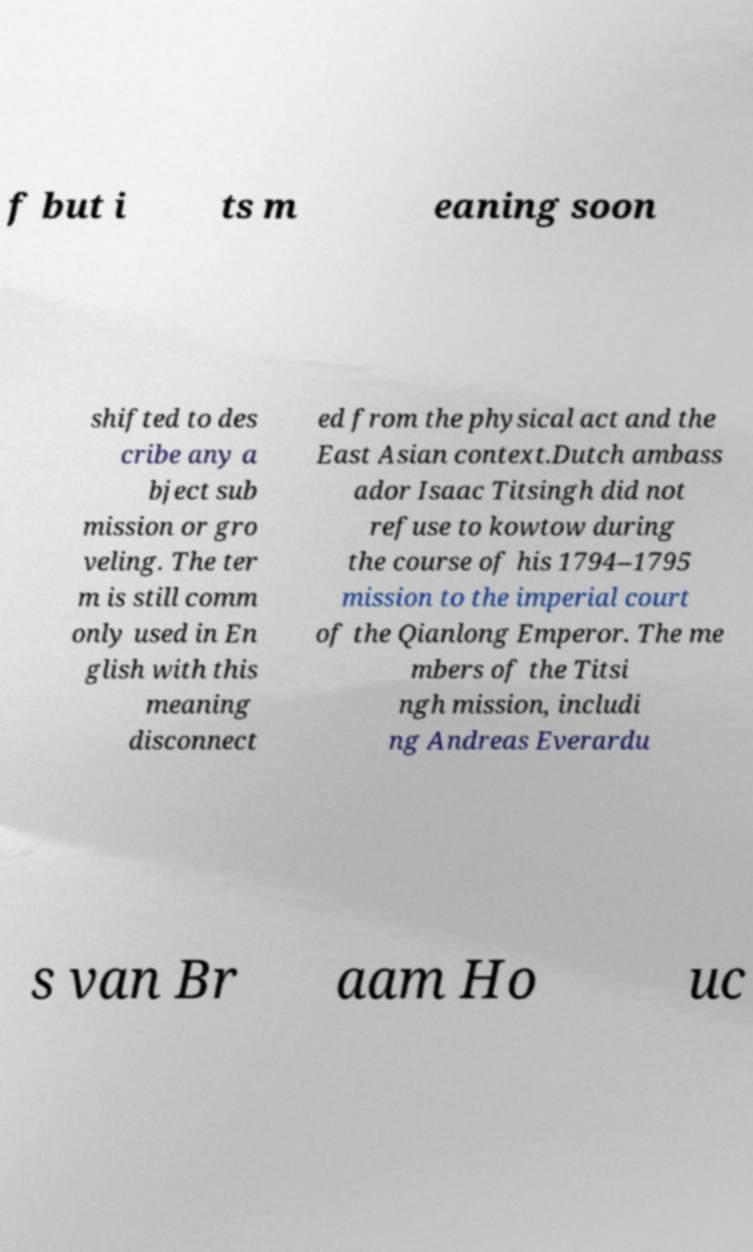There's text embedded in this image that I need extracted. Can you transcribe it verbatim? f but i ts m eaning soon shifted to des cribe any a bject sub mission or gro veling. The ter m is still comm only used in En glish with this meaning disconnect ed from the physical act and the East Asian context.Dutch ambass ador Isaac Titsingh did not refuse to kowtow during the course of his 1794–1795 mission to the imperial court of the Qianlong Emperor. The me mbers of the Titsi ngh mission, includi ng Andreas Everardu s van Br aam Ho uc 